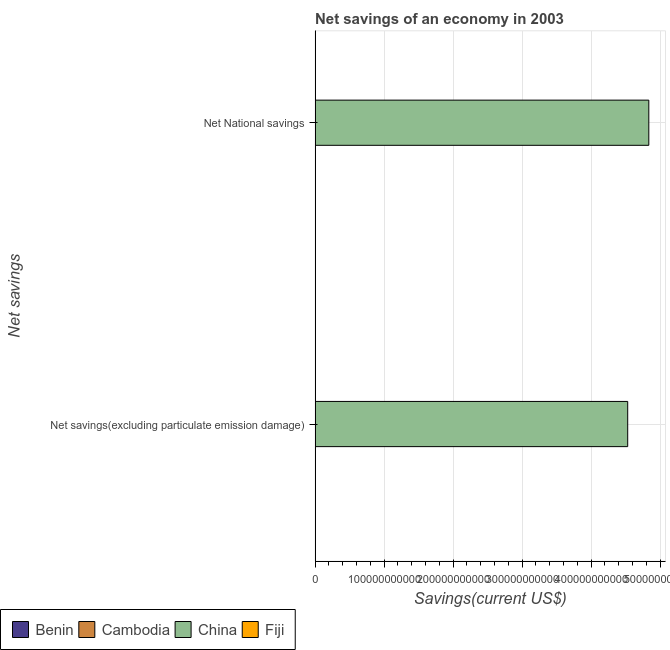What is the label of the 2nd group of bars from the top?
Provide a succinct answer. Net savings(excluding particulate emission damage). What is the net national savings in Fiji?
Give a very brief answer. 2.09e+08. Across all countries, what is the maximum net national savings?
Provide a succinct answer. 4.84e+11. Across all countries, what is the minimum net national savings?
Provide a succinct answer. 0. What is the total net savings(excluding particulate emission damage) in the graph?
Keep it short and to the point. 4.54e+11. What is the difference between the net savings(excluding particulate emission damage) in Fiji and that in Cambodia?
Provide a succinct answer. 6.93e+07. What is the difference between the net savings(excluding particulate emission damage) in China and the net national savings in Cambodia?
Provide a short and direct response. 4.53e+11. What is the average net national savings per country?
Offer a terse response. 1.21e+11. What is the difference between the net national savings and net savings(excluding particulate emission damage) in Cambodia?
Give a very brief answer. 7.81e+07. What is the ratio of the net savings(excluding particulate emission damage) in Fiji to that in China?
Give a very brief answer. 0. In how many countries, is the net national savings greater than the average net national savings taken over all countries?
Your answer should be compact. 1. Are all the bars in the graph horizontal?
Provide a short and direct response. Yes. What is the difference between two consecutive major ticks on the X-axis?
Keep it short and to the point. 1.00e+11. Are the values on the major ticks of X-axis written in scientific E-notation?
Make the answer very short. No. Does the graph contain grids?
Make the answer very short. Yes. Where does the legend appear in the graph?
Your answer should be very brief. Bottom left. How many legend labels are there?
Give a very brief answer. 4. How are the legend labels stacked?
Ensure brevity in your answer.  Horizontal. What is the title of the graph?
Give a very brief answer. Net savings of an economy in 2003. Does "Canada" appear as one of the legend labels in the graph?
Your answer should be compact. No. What is the label or title of the X-axis?
Your answer should be compact. Savings(current US$). What is the label or title of the Y-axis?
Give a very brief answer. Net savings. What is the Savings(current US$) in Benin in Net savings(excluding particulate emission damage)?
Offer a very short reply. 0. What is the Savings(current US$) of Cambodia in Net savings(excluding particulate emission damage)?
Provide a succinct answer. 2.59e+08. What is the Savings(current US$) in China in Net savings(excluding particulate emission damage)?
Offer a terse response. 4.53e+11. What is the Savings(current US$) in Fiji in Net savings(excluding particulate emission damage)?
Ensure brevity in your answer.  3.28e+08. What is the Savings(current US$) in Cambodia in Net National savings?
Your response must be concise. 3.37e+08. What is the Savings(current US$) of China in Net National savings?
Your response must be concise. 4.84e+11. What is the Savings(current US$) of Fiji in Net National savings?
Your answer should be compact. 2.09e+08. Across all Net savings, what is the maximum Savings(current US$) in Cambodia?
Your answer should be compact. 3.37e+08. Across all Net savings, what is the maximum Savings(current US$) of China?
Your answer should be compact. 4.84e+11. Across all Net savings, what is the maximum Savings(current US$) in Fiji?
Offer a very short reply. 3.28e+08. Across all Net savings, what is the minimum Savings(current US$) in Cambodia?
Give a very brief answer. 2.59e+08. Across all Net savings, what is the minimum Savings(current US$) in China?
Provide a succinct answer. 4.53e+11. Across all Net savings, what is the minimum Savings(current US$) of Fiji?
Your answer should be compact. 2.09e+08. What is the total Savings(current US$) of Benin in the graph?
Give a very brief answer. 0. What is the total Savings(current US$) in Cambodia in the graph?
Provide a succinct answer. 5.96e+08. What is the total Savings(current US$) in China in the graph?
Your answer should be very brief. 9.37e+11. What is the total Savings(current US$) of Fiji in the graph?
Offer a terse response. 5.37e+08. What is the difference between the Savings(current US$) of Cambodia in Net savings(excluding particulate emission damage) and that in Net National savings?
Your response must be concise. -7.81e+07. What is the difference between the Savings(current US$) of China in Net savings(excluding particulate emission damage) and that in Net National savings?
Your answer should be compact. -3.06e+1. What is the difference between the Savings(current US$) in Fiji in Net savings(excluding particulate emission damage) and that in Net National savings?
Make the answer very short. 1.19e+08. What is the difference between the Savings(current US$) in Cambodia in Net savings(excluding particulate emission damage) and the Savings(current US$) in China in Net National savings?
Your answer should be very brief. -4.83e+11. What is the difference between the Savings(current US$) in Cambodia in Net savings(excluding particulate emission damage) and the Savings(current US$) in Fiji in Net National savings?
Your answer should be very brief. 4.97e+07. What is the difference between the Savings(current US$) in China in Net savings(excluding particulate emission damage) and the Savings(current US$) in Fiji in Net National savings?
Your answer should be compact. 4.53e+11. What is the average Savings(current US$) of Benin per Net savings?
Provide a short and direct response. 0. What is the average Savings(current US$) of Cambodia per Net savings?
Provide a succinct answer. 2.98e+08. What is the average Savings(current US$) in China per Net savings?
Ensure brevity in your answer.  4.68e+11. What is the average Savings(current US$) of Fiji per Net savings?
Your answer should be very brief. 2.69e+08. What is the difference between the Savings(current US$) in Cambodia and Savings(current US$) in China in Net savings(excluding particulate emission damage)?
Your answer should be very brief. -4.53e+11. What is the difference between the Savings(current US$) of Cambodia and Savings(current US$) of Fiji in Net savings(excluding particulate emission damage)?
Offer a terse response. -6.93e+07. What is the difference between the Savings(current US$) of China and Savings(current US$) of Fiji in Net savings(excluding particulate emission damage)?
Your answer should be very brief. 4.53e+11. What is the difference between the Savings(current US$) in Cambodia and Savings(current US$) in China in Net National savings?
Keep it short and to the point. -4.83e+11. What is the difference between the Savings(current US$) of Cambodia and Savings(current US$) of Fiji in Net National savings?
Offer a terse response. 1.28e+08. What is the difference between the Savings(current US$) in China and Savings(current US$) in Fiji in Net National savings?
Give a very brief answer. 4.83e+11. What is the ratio of the Savings(current US$) in Cambodia in Net savings(excluding particulate emission damage) to that in Net National savings?
Give a very brief answer. 0.77. What is the ratio of the Savings(current US$) in China in Net savings(excluding particulate emission damage) to that in Net National savings?
Your response must be concise. 0.94. What is the ratio of the Savings(current US$) in Fiji in Net savings(excluding particulate emission damage) to that in Net National savings?
Your response must be concise. 1.57. What is the difference between the highest and the second highest Savings(current US$) in Cambodia?
Offer a very short reply. 7.81e+07. What is the difference between the highest and the second highest Savings(current US$) in China?
Keep it short and to the point. 3.06e+1. What is the difference between the highest and the second highest Savings(current US$) in Fiji?
Provide a short and direct response. 1.19e+08. What is the difference between the highest and the lowest Savings(current US$) in Cambodia?
Offer a terse response. 7.81e+07. What is the difference between the highest and the lowest Savings(current US$) of China?
Make the answer very short. 3.06e+1. What is the difference between the highest and the lowest Savings(current US$) in Fiji?
Your response must be concise. 1.19e+08. 